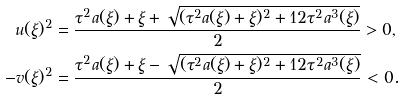<formula> <loc_0><loc_0><loc_500><loc_500>u ( \xi ) ^ { 2 } & = \frac { \tau ^ { 2 } a ( \xi ) + \xi + \sqrt { ( \tau ^ { 2 } a ( \xi ) + \xi ) ^ { 2 } + 1 2 \tau ^ { 2 } a ^ { 3 } ( \xi ) } } { 2 } > 0 , \\ - v ( \xi ) ^ { 2 } & = \frac { \tau ^ { 2 } a ( \xi ) + \xi - \sqrt { ( \tau ^ { 2 } a ( \xi ) + \xi ) ^ { 2 } + 1 2 \tau ^ { 2 } a ^ { 3 } ( \xi ) } } { 2 } < 0 .</formula> 